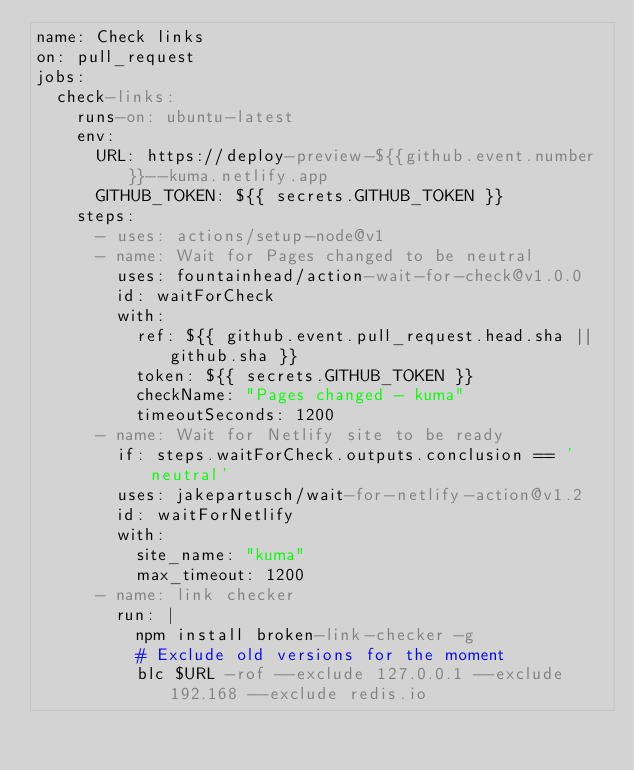<code> <loc_0><loc_0><loc_500><loc_500><_YAML_>name: Check links
on: pull_request
jobs:
  check-links:
    runs-on: ubuntu-latest
    env:
      URL: https://deploy-preview-${{github.event.number}}--kuma.netlify.app
      GITHUB_TOKEN: ${{ secrets.GITHUB_TOKEN }}
    steps:
      - uses: actions/setup-node@v1
      - name: Wait for Pages changed to be neutral
        uses: fountainhead/action-wait-for-check@v1.0.0
        id: waitForCheck
        with:
          ref: ${{ github.event.pull_request.head.sha || github.sha }}
          token: ${{ secrets.GITHUB_TOKEN }}
          checkName: "Pages changed - kuma"
          timeoutSeconds: 1200
      - name: Wait for Netlify site to be ready
        if: steps.waitForCheck.outputs.conclusion == 'neutral'
        uses: jakepartusch/wait-for-netlify-action@v1.2
        id: waitForNetlify
        with:
          site_name: "kuma"
          max_timeout: 1200
      - name: link checker
        run: |
          npm install broken-link-checker -g
          # Exclude old versions for the moment
          blc $URL -rof --exclude 127.0.0.1 --exclude 192.168 --exclude redis.io
</code> 